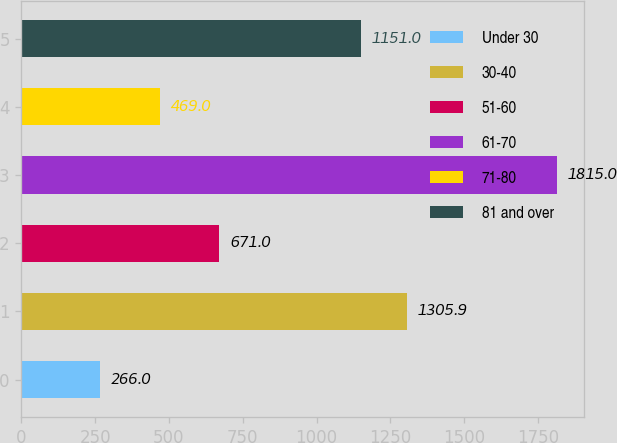<chart> <loc_0><loc_0><loc_500><loc_500><bar_chart><fcel>Under 30<fcel>30-40<fcel>51-60<fcel>61-70<fcel>71-80<fcel>81 and over<nl><fcel>266<fcel>1305.9<fcel>671<fcel>1815<fcel>469<fcel>1151<nl></chart> 